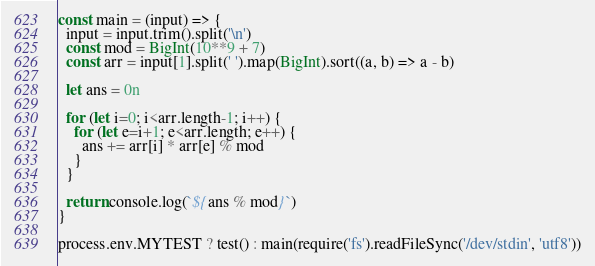<code> <loc_0><loc_0><loc_500><loc_500><_JavaScript_>const main = (input) => {
  input = input.trim().split('\n')
  const mod = BigInt(10**9 + 7)
  const arr = input[1].split(' ').map(BigInt).sort((a, b) => a - b)

  let ans = 0n

  for (let i=0; i<arr.length-1; i++) {
    for (let e=i+1; e<arr.length; e++) {
      ans += arr[i] * arr[e] % mod
    }
  }

  return console.log(`${ans % mod}`)
}

process.env.MYTEST ? test() : main(require('fs').readFileSync('/dev/stdin', 'utf8'))</code> 